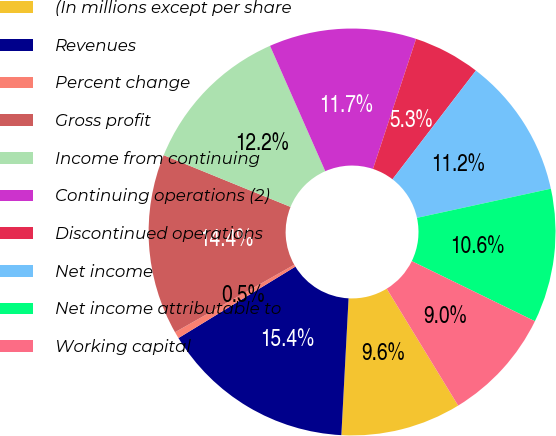Convert chart. <chart><loc_0><loc_0><loc_500><loc_500><pie_chart><fcel>(In millions except per share<fcel>Revenues<fcel>Percent change<fcel>Gross profit<fcel>Income from continuing<fcel>Continuing operations (2)<fcel>Discontinued operations<fcel>Net income<fcel>Net income attributable to<fcel>Working capital<nl><fcel>9.57%<fcel>15.43%<fcel>0.53%<fcel>14.36%<fcel>12.23%<fcel>11.7%<fcel>5.32%<fcel>11.17%<fcel>10.64%<fcel>9.04%<nl></chart> 